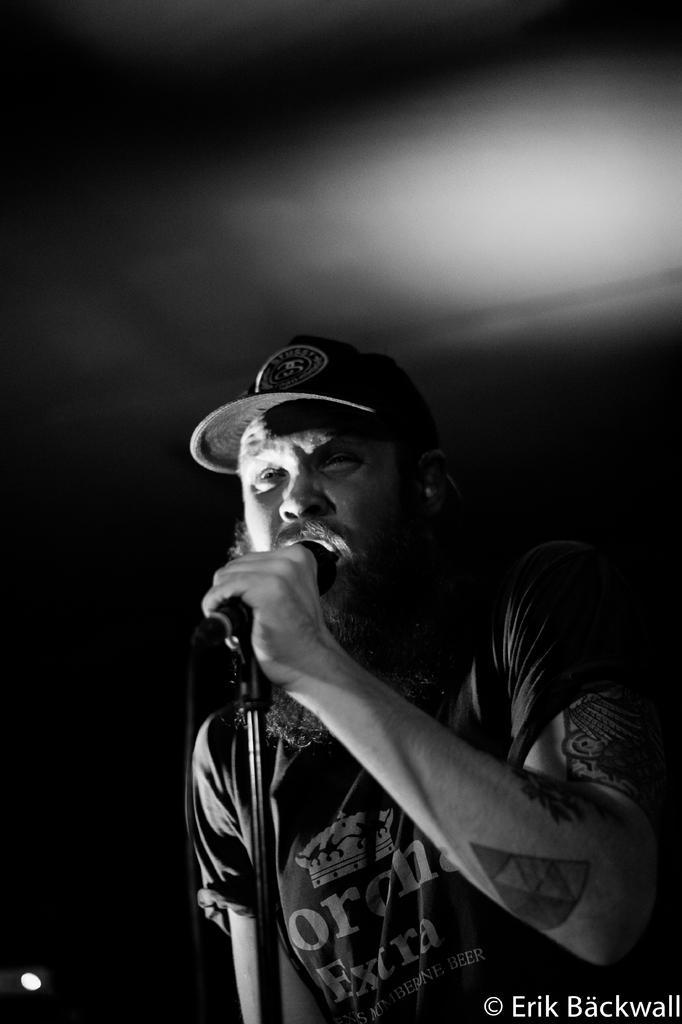In one or two sentences, can you explain what this image depicts? As we can see in the image there is a man holding mic in his hand and singing. 